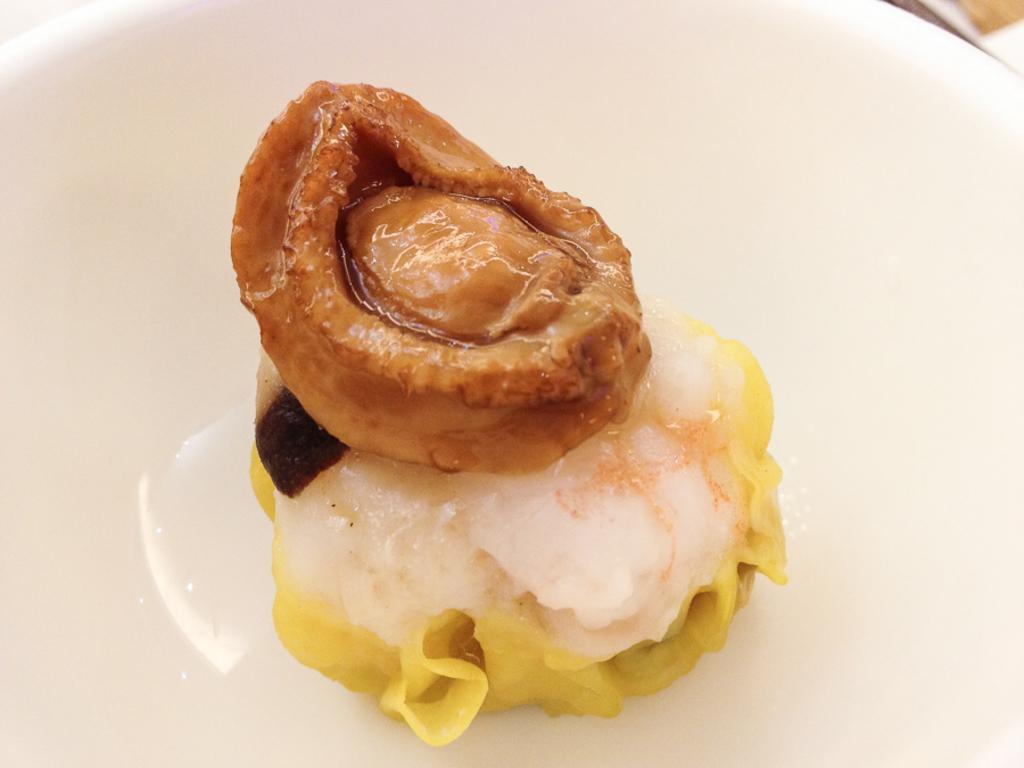How would you summarize this image in a sentence or two? In this image we can see some food items on the plate. 